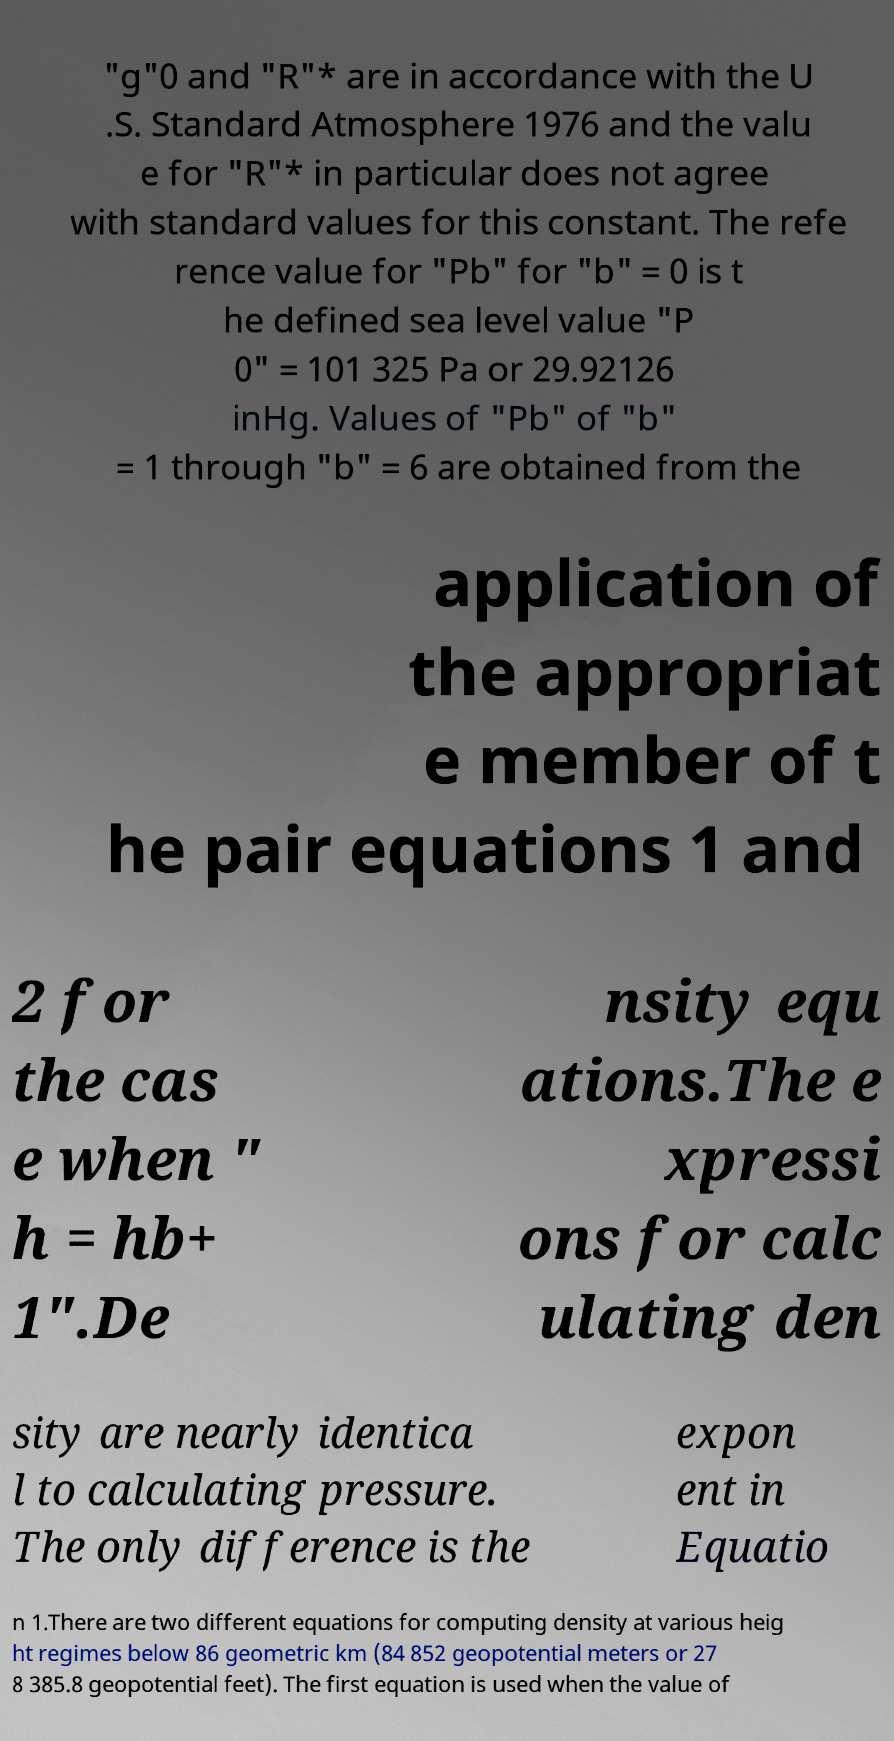For documentation purposes, I need the text within this image transcribed. Could you provide that? "g"0 and "R"* are in accordance with the U .S. Standard Atmosphere 1976 and the valu e for "R"* in particular does not agree with standard values for this constant. The refe rence value for "Pb" for "b" = 0 is t he defined sea level value "P 0" = 101 325 Pa or 29.92126 inHg. Values of "Pb" of "b" = 1 through "b" = 6 are obtained from the application of the appropriat e member of t he pair equations 1 and 2 for the cas e when " h = hb+ 1".De nsity equ ations.The e xpressi ons for calc ulating den sity are nearly identica l to calculating pressure. The only difference is the expon ent in Equatio n 1.There are two different equations for computing density at various heig ht regimes below 86 geometric km (84 852 geopotential meters or 27 8 385.8 geopotential feet). The first equation is used when the value of 